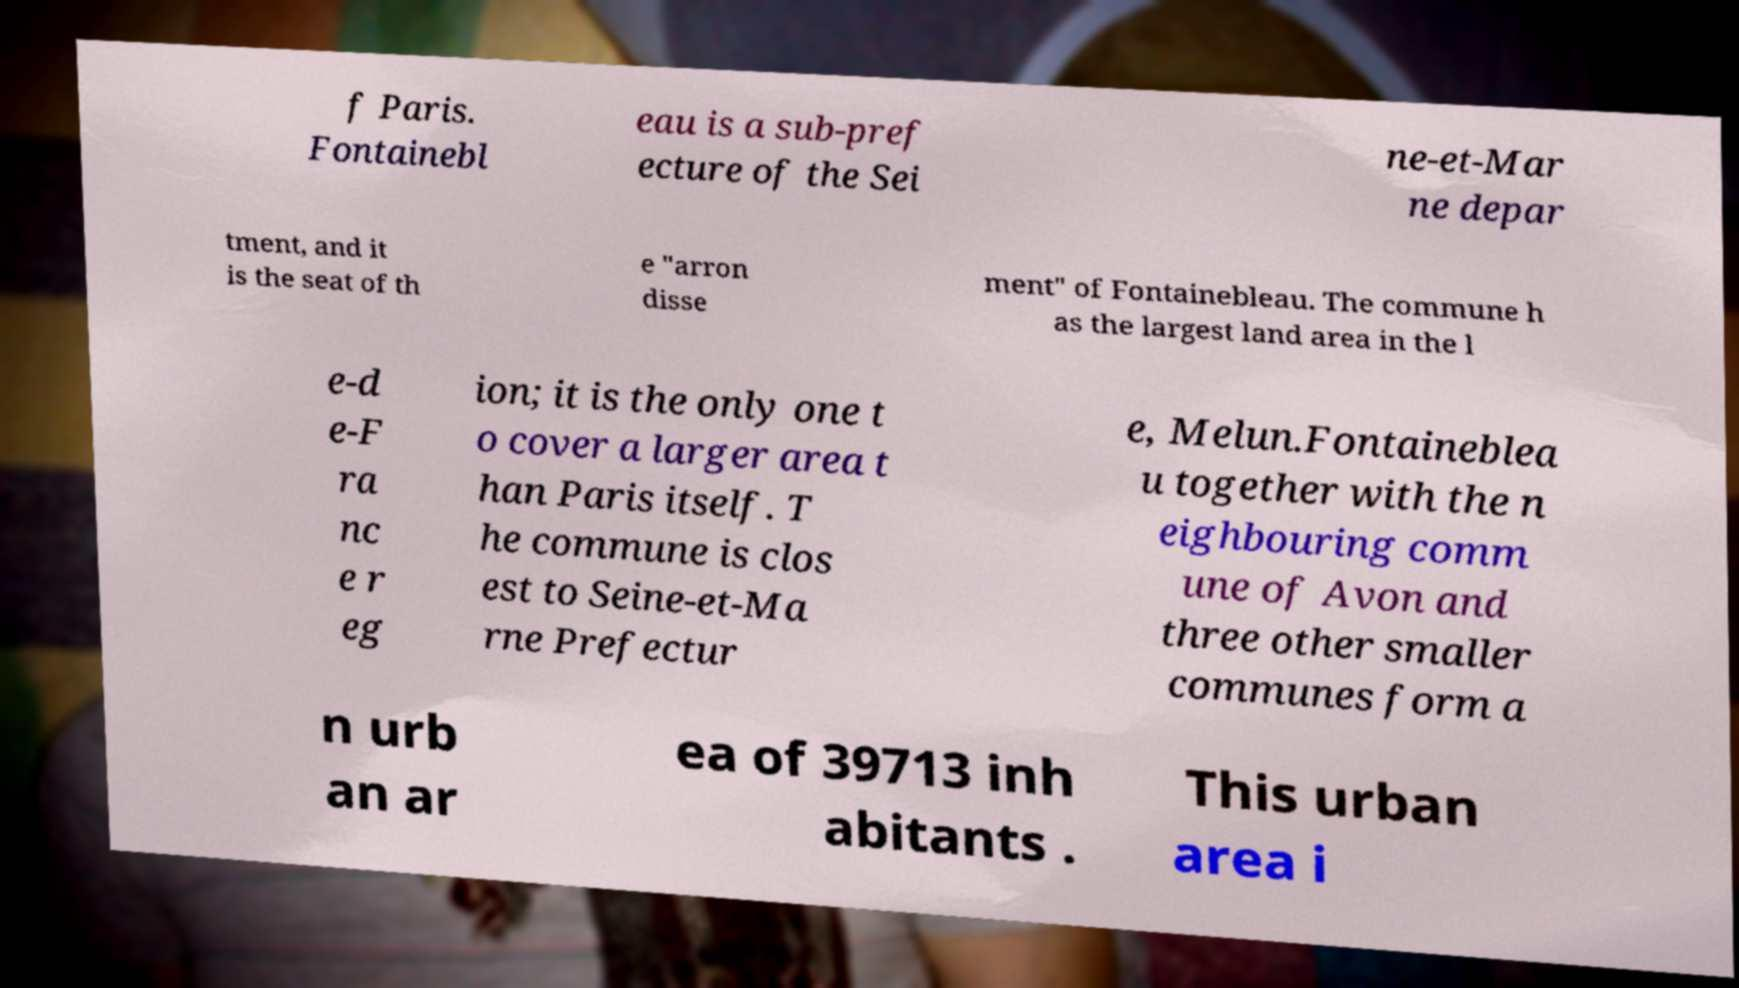Please read and relay the text visible in this image. What does it say? f Paris. Fontainebl eau is a sub-pref ecture of the Sei ne-et-Mar ne depar tment, and it is the seat of th e "arron disse ment" of Fontainebleau. The commune h as the largest land area in the l e-d e-F ra nc e r eg ion; it is the only one t o cover a larger area t han Paris itself. T he commune is clos est to Seine-et-Ma rne Prefectur e, Melun.Fontaineblea u together with the n eighbouring comm une of Avon and three other smaller communes form a n urb an ar ea of 39713 inh abitants . This urban area i 